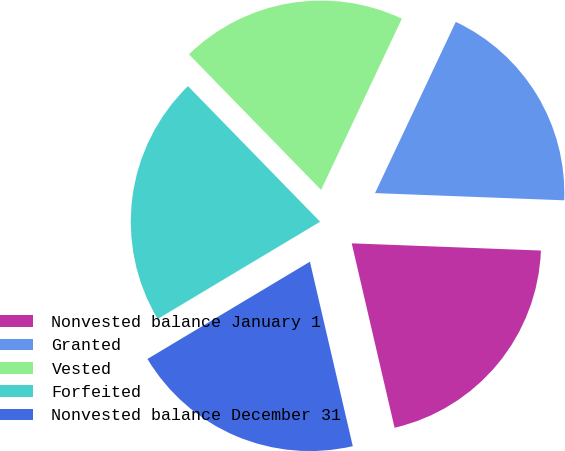Convert chart to OTSL. <chart><loc_0><loc_0><loc_500><loc_500><pie_chart><fcel>Nonvested balance January 1<fcel>Granted<fcel>Vested<fcel>Forfeited<fcel>Nonvested balance December 31<nl><fcel>20.76%<fcel>18.59%<fcel>19.31%<fcel>21.29%<fcel>20.05%<nl></chart> 